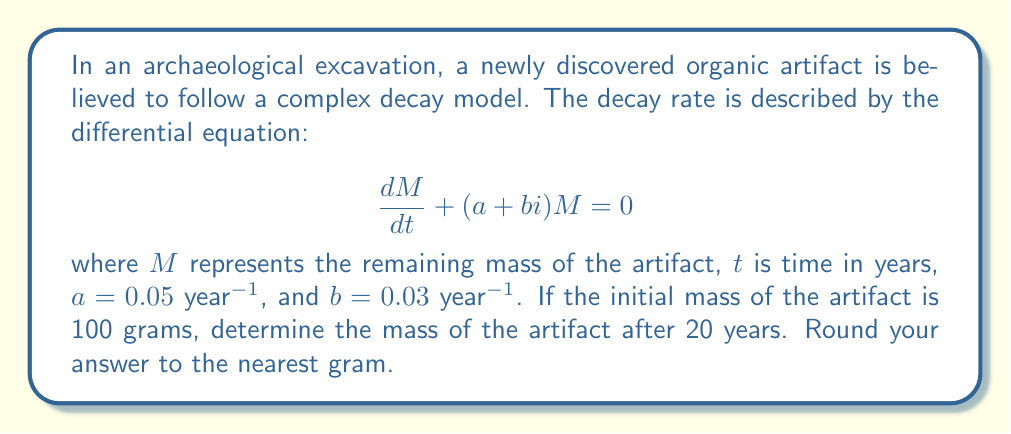Could you help me with this problem? To solve this problem, we'll follow these steps:

1) The general solution to the differential equation $\frac{dM}{dt} + (a + bi)M = 0$ is:

   $$M(t) = M_0 e^{-(a+bi)t}$$

   where $M_0$ is the initial mass.

2) Given $M_0 = 100$ grams, $a = 0.05$ year$^{-1}$, $b = 0.03$ year$^{-1}$, and $t = 20$ years, we can substitute these values:

   $$M(20) = 100 e^{-(0.05 + 0.03i)20}$$

3) Let's simplify the exponent:

   $$-(0.05 + 0.03i)20 = -1 - 0.6i$$

4) Now our equation is:

   $$M(20) = 100 e^{-1 - 0.6i}$$

5) To evaluate this, we can use Euler's formula: $e^{x+yi} = e^x(\cos y + i\sin y)$

   $$M(20) = 100 e^{-1}(\cos(-0.6) + i\sin(-0.6))$$

6) Evaluate each part:
   
   $e^{-1} \approx 0.3679$
   $\cos(-0.6) \approx 0.8253$
   $\sin(-0.6) \approx -0.5646$

7) Substituting:

   $$M(20) = 100 \cdot 0.3679(0.8253 - 0.5646i)$$

8) Multiply:

   $$M(20) = 30.37 - 20.77i$$

9) To get the magnitude (actual mass), we take the absolute value:

   $$|M(20)| = \sqrt{30.37^2 + (-20.77)^2} \approx 36.84$$
Answer: The mass of the artifact after 20 years is approximately 37 grams (rounded to the nearest gram). 